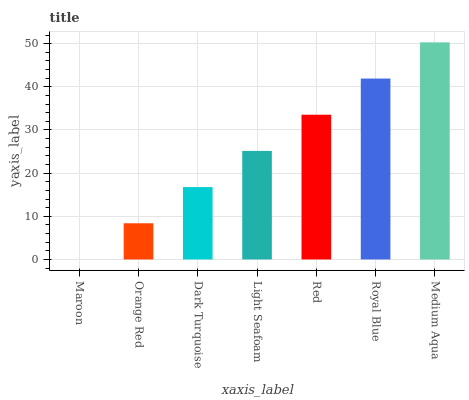Is Maroon the minimum?
Answer yes or no. Yes. Is Medium Aqua the maximum?
Answer yes or no. Yes. Is Orange Red the minimum?
Answer yes or no. No. Is Orange Red the maximum?
Answer yes or no. No. Is Orange Red greater than Maroon?
Answer yes or no. Yes. Is Maroon less than Orange Red?
Answer yes or no. Yes. Is Maroon greater than Orange Red?
Answer yes or no. No. Is Orange Red less than Maroon?
Answer yes or no. No. Is Light Seafoam the high median?
Answer yes or no. Yes. Is Light Seafoam the low median?
Answer yes or no. Yes. Is Orange Red the high median?
Answer yes or no. No. Is Medium Aqua the low median?
Answer yes or no. No. 